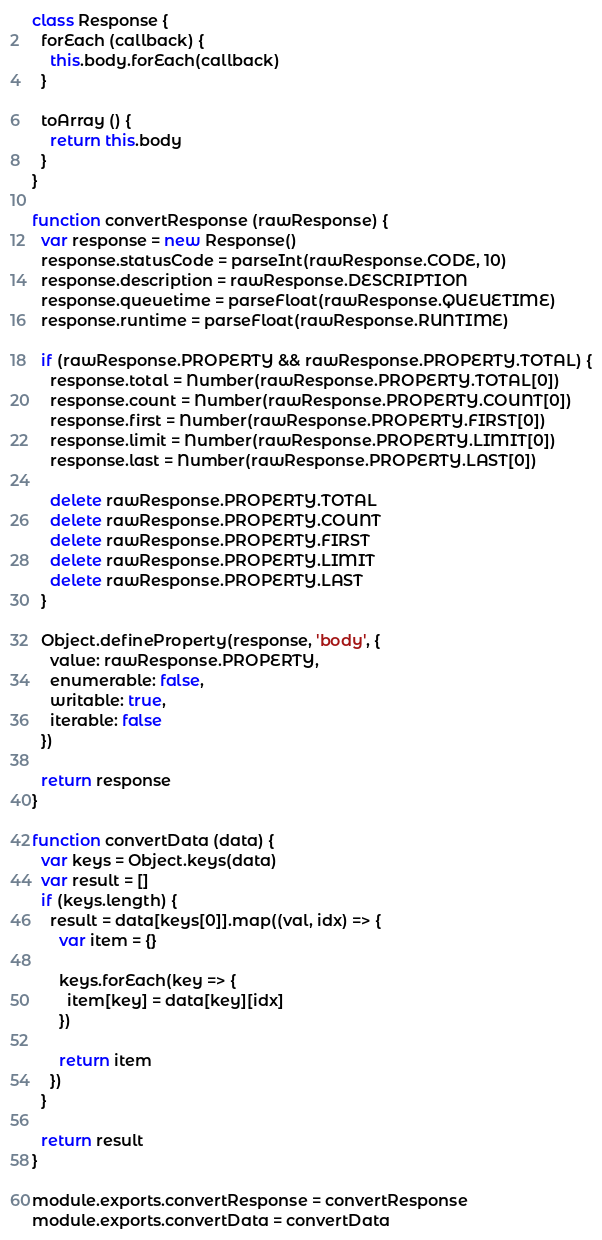Convert code to text. <code><loc_0><loc_0><loc_500><loc_500><_JavaScript_>class Response {
  forEach (callback) {
    this.body.forEach(callback)
  }

  toArray () {
    return this.body
  }
}

function convertResponse (rawResponse) {
  var response = new Response()
  response.statusCode = parseInt(rawResponse.CODE, 10)
  response.description = rawResponse.DESCRIPTION
  response.queuetime = parseFloat(rawResponse.QUEUETIME)
  response.runtime = parseFloat(rawResponse.RUNTIME)

  if (rawResponse.PROPERTY && rawResponse.PROPERTY.TOTAL) {
    response.total = Number(rawResponse.PROPERTY.TOTAL[0])
    response.count = Number(rawResponse.PROPERTY.COUNT[0])
    response.first = Number(rawResponse.PROPERTY.FIRST[0])
    response.limit = Number(rawResponse.PROPERTY.LIMIT[0])
    response.last = Number(rawResponse.PROPERTY.LAST[0])

    delete rawResponse.PROPERTY.TOTAL
    delete rawResponse.PROPERTY.COUNT
    delete rawResponse.PROPERTY.FIRST
    delete rawResponse.PROPERTY.LIMIT
    delete rawResponse.PROPERTY.LAST
  }

  Object.defineProperty(response, 'body', {
    value: rawResponse.PROPERTY,
    enumerable: false,
    writable: true,
    iterable: false
  })

  return response
}

function convertData (data) {
  var keys = Object.keys(data)
  var result = []
  if (keys.length) {
    result = data[keys[0]].map((val, idx) => {
      var item = {}

      keys.forEach(key => {
        item[key] = data[key][idx]
      })

      return item
    })
  }

  return result
}

module.exports.convertResponse = convertResponse
module.exports.convertData = convertData
</code> 